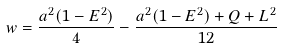Convert formula to latex. <formula><loc_0><loc_0><loc_500><loc_500>w = \frac { a ^ { 2 } ( 1 - E ^ { 2 } ) } { 4 } - \frac { a ^ { 2 } ( 1 - E ^ { 2 } ) + Q + L ^ { 2 } } { 1 2 }</formula> 